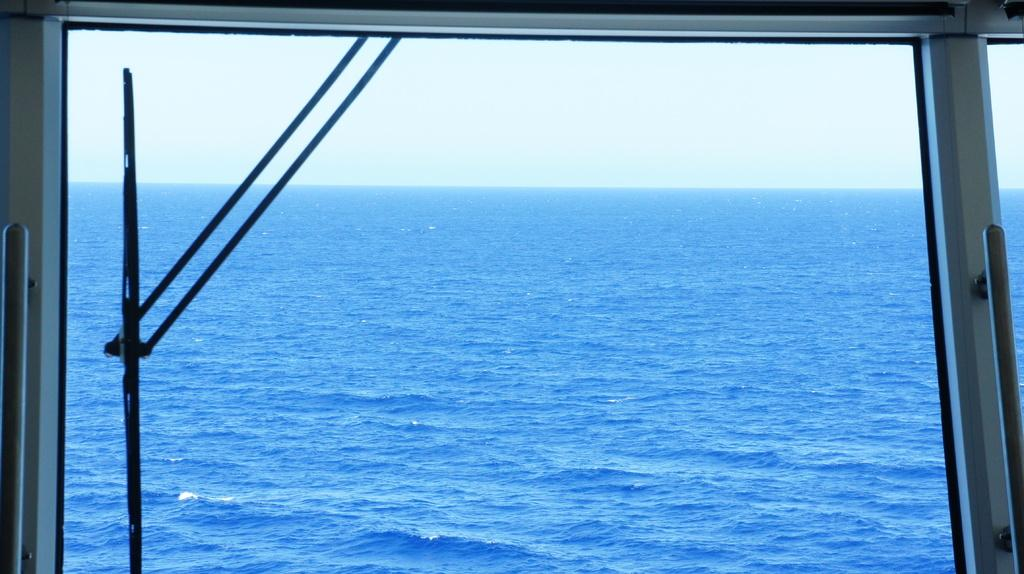What object is present in the image that can hold liquid? There is a glass in the image that can hold liquid. What is visible through the glass? Water is visible through the glass. What is located on the left side of the image? There is a wiper on the left side of the image. What can be seen in the background of the image? The sky is visible in the background of the image. How many fingers can be seen pointing at the glass in the image? There are no fingers visible in the image pointing at the glass. What type of snake is slithering across the sky in the background of the image? There is no snake present in the image; the background only shows the sky. 